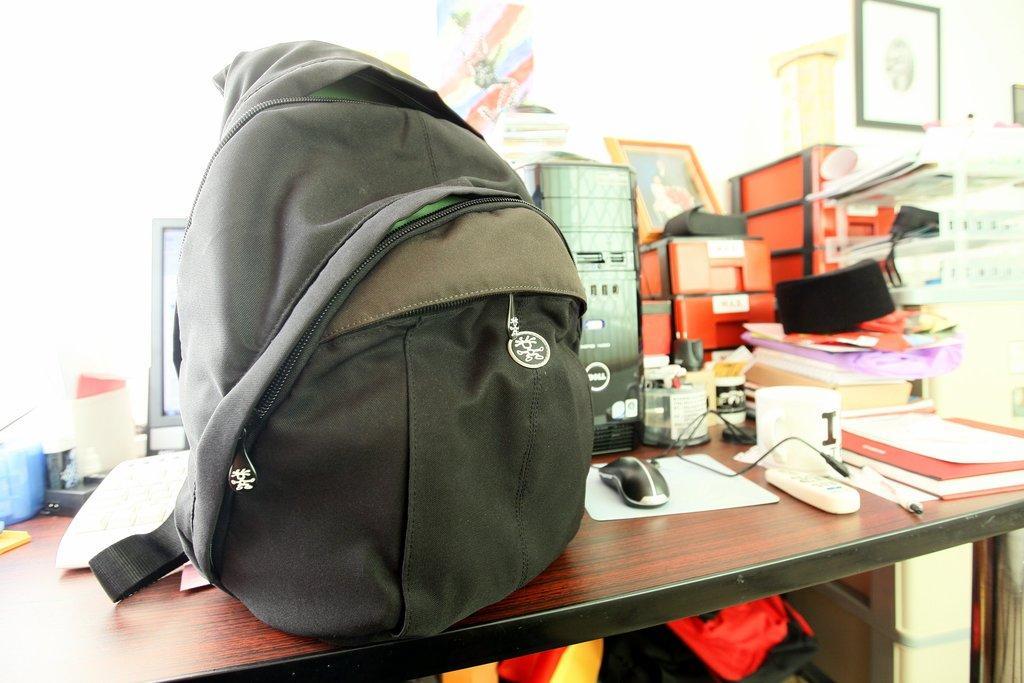How would you summarize this image in a sentence or two? In this image I can see a bag and a computer on this table. I can also see few more stuffs over here. 